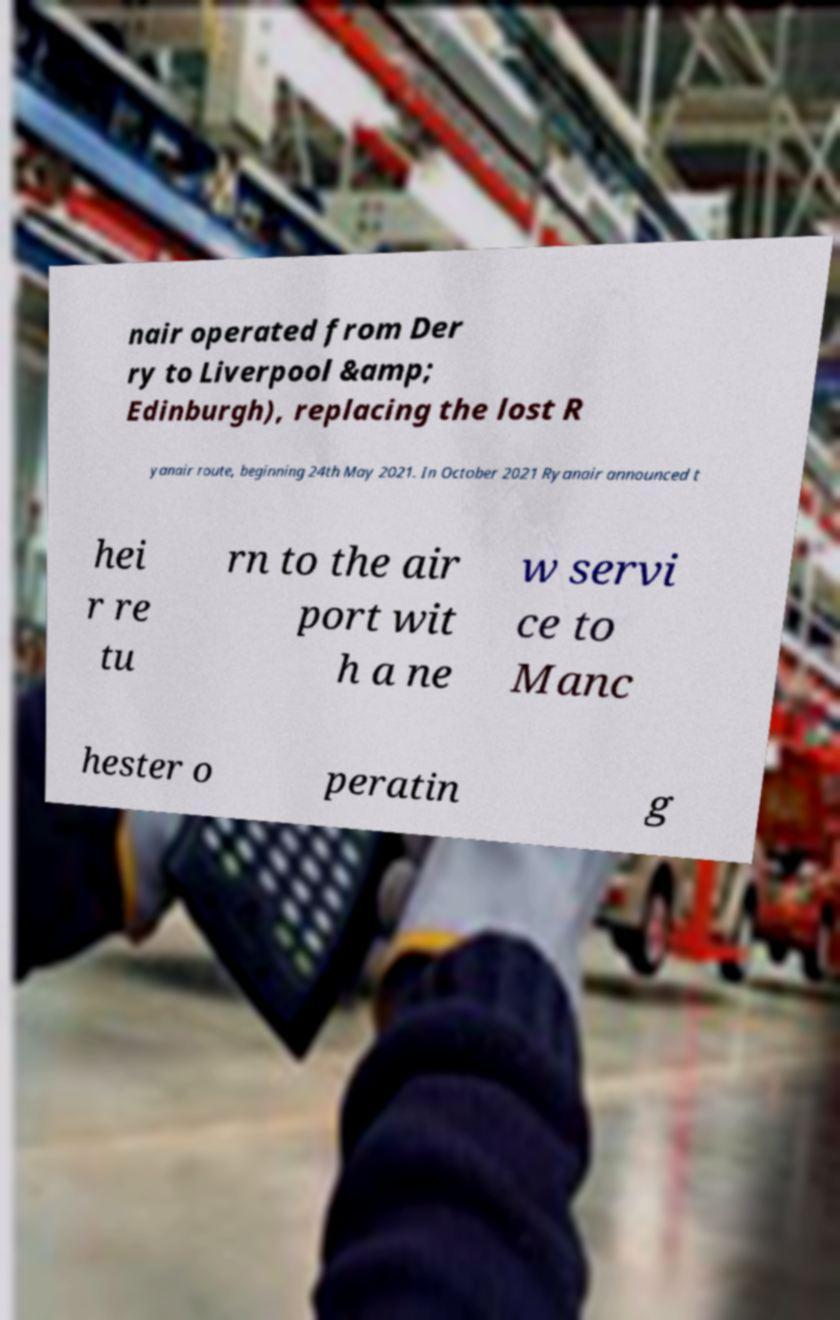Please read and relay the text visible in this image. What does it say? nair operated from Der ry to Liverpool &amp; Edinburgh), replacing the lost R yanair route, beginning 24th May 2021. In October 2021 Ryanair announced t hei r re tu rn to the air port wit h a ne w servi ce to Manc hester o peratin g 